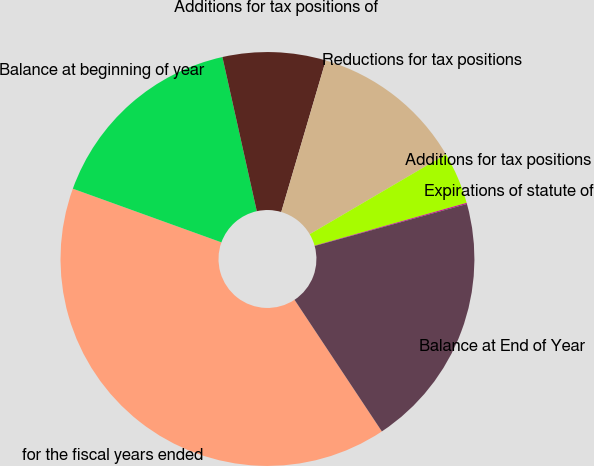Convert chart to OTSL. <chart><loc_0><loc_0><loc_500><loc_500><pie_chart><fcel>for the fiscal years ended<fcel>Balance at beginning of year<fcel>Additions for tax positions of<fcel>Reductions for tax positions<fcel>Additions for tax positions<fcel>Expirations of statute of<fcel>Balance at End of Year<nl><fcel>39.84%<fcel>15.99%<fcel>8.04%<fcel>12.01%<fcel>4.07%<fcel>0.09%<fcel>19.96%<nl></chart> 